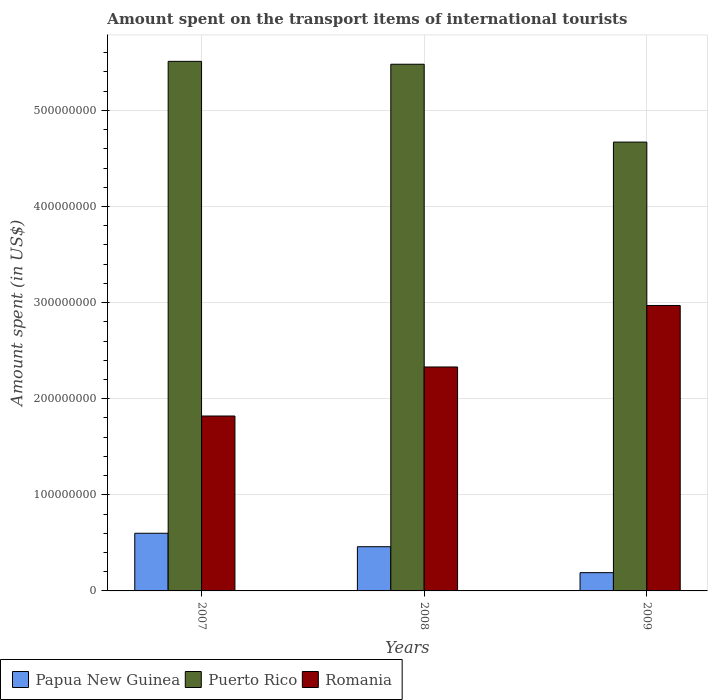How many different coloured bars are there?
Ensure brevity in your answer.  3. How many groups of bars are there?
Provide a short and direct response. 3. How many bars are there on the 3rd tick from the left?
Keep it short and to the point. 3. How many bars are there on the 3rd tick from the right?
Your response must be concise. 3. In how many cases, is the number of bars for a given year not equal to the number of legend labels?
Keep it short and to the point. 0. What is the amount spent on the transport items of international tourists in Puerto Rico in 2009?
Provide a short and direct response. 4.67e+08. Across all years, what is the maximum amount spent on the transport items of international tourists in Papua New Guinea?
Offer a very short reply. 6.00e+07. Across all years, what is the minimum amount spent on the transport items of international tourists in Romania?
Make the answer very short. 1.82e+08. In which year was the amount spent on the transport items of international tourists in Puerto Rico maximum?
Give a very brief answer. 2007. What is the total amount spent on the transport items of international tourists in Papua New Guinea in the graph?
Offer a terse response. 1.25e+08. What is the difference between the amount spent on the transport items of international tourists in Puerto Rico in 2008 and that in 2009?
Ensure brevity in your answer.  8.10e+07. What is the difference between the amount spent on the transport items of international tourists in Romania in 2008 and the amount spent on the transport items of international tourists in Papua New Guinea in 2009?
Give a very brief answer. 2.14e+08. What is the average amount spent on the transport items of international tourists in Papua New Guinea per year?
Provide a short and direct response. 4.17e+07. In the year 2009, what is the difference between the amount spent on the transport items of international tourists in Papua New Guinea and amount spent on the transport items of international tourists in Puerto Rico?
Your answer should be very brief. -4.48e+08. What is the ratio of the amount spent on the transport items of international tourists in Papua New Guinea in 2008 to that in 2009?
Ensure brevity in your answer.  2.42. Is the amount spent on the transport items of international tourists in Puerto Rico in 2007 less than that in 2008?
Ensure brevity in your answer.  No. What is the difference between the highest and the second highest amount spent on the transport items of international tourists in Papua New Guinea?
Offer a terse response. 1.40e+07. What is the difference between the highest and the lowest amount spent on the transport items of international tourists in Romania?
Give a very brief answer. 1.15e+08. Is the sum of the amount spent on the transport items of international tourists in Romania in 2007 and 2009 greater than the maximum amount spent on the transport items of international tourists in Papua New Guinea across all years?
Your answer should be very brief. Yes. What does the 1st bar from the left in 2008 represents?
Offer a terse response. Papua New Guinea. What does the 2nd bar from the right in 2007 represents?
Your answer should be compact. Puerto Rico. Is it the case that in every year, the sum of the amount spent on the transport items of international tourists in Puerto Rico and amount spent on the transport items of international tourists in Romania is greater than the amount spent on the transport items of international tourists in Papua New Guinea?
Your answer should be compact. Yes. How many years are there in the graph?
Make the answer very short. 3. Does the graph contain any zero values?
Your response must be concise. No. Where does the legend appear in the graph?
Provide a short and direct response. Bottom left. How many legend labels are there?
Provide a succinct answer. 3. What is the title of the graph?
Offer a very short reply. Amount spent on the transport items of international tourists. Does "Sweden" appear as one of the legend labels in the graph?
Provide a short and direct response. No. What is the label or title of the Y-axis?
Make the answer very short. Amount spent (in US$). What is the Amount spent (in US$) of Papua New Guinea in 2007?
Ensure brevity in your answer.  6.00e+07. What is the Amount spent (in US$) of Puerto Rico in 2007?
Your answer should be compact. 5.51e+08. What is the Amount spent (in US$) of Romania in 2007?
Provide a succinct answer. 1.82e+08. What is the Amount spent (in US$) of Papua New Guinea in 2008?
Offer a very short reply. 4.60e+07. What is the Amount spent (in US$) of Puerto Rico in 2008?
Offer a terse response. 5.48e+08. What is the Amount spent (in US$) of Romania in 2008?
Give a very brief answer. 2.33e+08. What is the Amount spent (in US$) of Papua New Guinea in 2009?
Your answer should be compact. 1.90e+07. What is the Amount spent (in US$) of Puerto Rico in 2009?
Your answer should be compact. 4.67e+08. What is the Amount spent (in US$) in Romania in 2009?
Provide a short and direct response. 2.97e+08. Across all years, what is the maximum Amount spent (in US$) in Papua New Guinea?
Keep it short and to the point. 6.00e+07. Across all years, what is the maximum Amount spent (in US$) of Puerto Rico?
Make the answer very short. 5.51e+08. Across all years, what is the maximum Amount spent (in US$) of Romania?
Give a very brief answer. 2.97e+08. Across all years, what is the minimum Amount spent (in US$) in Papua New Guinea?
Keep it short and to the point. 1.90e+07. Across all years, what is the minimum Amount spent (in US$) in Puerto Rico?
Make the answer very short. 4.67e+08. Across all years, what is the minimum Amount spent (in US$) in Romania?
Offer a very short reply. 1.82e+08. What is the total Amount spent (in US$) in Papua New Guinea in the graph?
Provide a short and direct response. 1.25e+08. What is the total Amount spent (in US$) of Puerto Rico in the graph?
Provide a succinct answer. 1.57e+09. What is the total Amount spent (in US$) of Romania in the graph?
Keep it short and to the point. 7.12e+08. What is the difference between the Amount spent (in US$) in Papua New Guinea in 2007 and that in 2008?
Keep it short and to the point. 1.40e+07. What is the difference between the Amount spent (in US$) of Puerto Rico in 2007 and that in 2008?
Provide a short and direct response. 3.00e+06. What is the difference between the Amount spent (in US$) of Romania in 2007 and that in 2008?
Your response must be concise. -5.10e+07. What is the difference between the Amount spent (in US$) in Papua New Guinea in 2007 and that in 2009?
Make the answer very short. 4.10e+07. What is the difference between the Amount spent (in US$) of Puerto Rico in 2007 and that in 2009?
Offer a terse response. 8.40e+07. What is the difference between the Amount spent (in US$) in Romania in 2007 and that in 2009?
Your response must be concise. -1.15e+08. What is the difference between the Amount spent (in US$) in Papua New Guinea in 2008 and that in 2009?
Your answer should be very brief. 2.70e+07. What is the difference between the Amount spent (in US$) in Puerto Rico in 2008 and that in 2009?
Make the answer very short. 8.10e+07. What is the difference between the Amount spent (in US$) of Romania in 2008 and that in 2009?
Offer a terse response. -6.40e+07. What is the difference between the Amount spent (in US$) in Papua New Guinea in 2007 and the Amount spent (in US$) in Puerto Rico in 2008?
Your response must be concise. -4.88e+08. What is the difference between the Amount spent (in US$) of Papua New Guinea in 2007 and the Amount spent (in US$) of Romania in 2008?
Provide a short and direct response. -1.73e+08. What is the difference between the Amount spent (in US$) of Puerto Rico in 2007 and the Amount spent (in US$) of Romania in 2008?
Your answer should be very brief. 3.18e+08. What is the difference between the Amount spent (in US$) in Papua New Guinea in 2007 and the Amount spent (in US$) in Puerto Rico in 2009?
Give a very brief answer. -4.07e+08. What is the difference between the Amount spent (in US$) in Papua New Guinea in 2007 and the Amount spent (in US$) in Romania in 2009?
Your answer should be compact. -2.37e+08. What is the difference between the Amount spent (in US$) of Puerto Rico in 2007 and the Amount spent (in US$) of Romania in 2009?
Keep it short and to the point. 2.54e+08. What is the difference between the Amount spent (in US$) in Papua New Guinea in 2008 and the Amount spent (in US$) in Puerto Rico in 2009?
Offer a terse response. -4.21e+08. What is the difference between the Amount spent (in US$) of Papua New Guinea in 2008 and the Amount spent (in US$) of Romania in 2009?
Provide a short and direct response. -2.51e+08. What is the difference between the Amount spent (in US$) in Puerto Rico in 2008 and the Amount spent (in US$) in Romania in 2009?
Give a very brief answer. 2.51e+08. What is the average Amount spent (in US$) in Papua New Guinea per year?
Your answer should be compact. 4.17e+07. What is the average Amount spent (in US$) of Puerto Rico per year?
Give a very brief answer. 5.22e+08. What is the average Amount spent (in US$) of Romania per year?
Your answer should be compact. 2.37e+08. In the year 2007, what is the difference between the Amount spent (in US$) in Papua New Guinea and Amount spent (in US$) in Puerto Rico?
Your answer should be compact. -4.91e+08. In the year 2007, what is the difference between the Amount spent (in US$) of Papua New Guinea and Amount spent (in US$) of Romania?
Give a very brief answer. -1.22e+08. In the year 2007, what is the difference between the Amount spent (in US$) in Puerto Rico and Amount spent (in US$) in Romania?
Offer a very short reply. 3.69e+08. In the year 2008, what is the difference between the Amount spent (in US$) in Papua New Guinea and Amount spent (in US$) in Puerto Rico?
Provide a succinct answer. -5.02e+08. In the year 2008, what is the difference between the Amount spent (in US$) in Papua New Guinea and Amount spent (in US$) in Romania?
Give a very brief answer. -1.87e+08. In the year 2008, what is the difference between the Amount spent (in US$) in Puerto Rico and Amount spent (in US$) in Romania?
Offer a terse response. 3.15e+08. In the year 2009, what is the difference between the Amount spent (in US$) in Papua New Guinea and Amount spent (in US$) in Puerto Rico?
Provide a short and direct response. -4.48e+08. In the year 2009, what is the difference between the Amount spent (in US$) in Papua New Guinea and Amount spent (in US$) in Romania?
Your answer should be very brief. -2.78e+08. In the year 2009, what is the difference between the Amount spent (in US$) of Puerto Rico and Amount spent (in US$) of Romania?
Your response must be concise. 1.70e+08. What is the ratio of the Amount spent (in US$) of Papua New Guinea in 2007 to that in 2008?
Offer a terse response. 1.3. What is the ratio of the Amount spent (in US$) in Romania in 2007 to that in 2008?
Ensure brevity in your answer.  0.78. What is the ratio of the Amount spent (in US$) of Papua New Guinea in 2007 to that in 2009?
Keep it short and to the point. 3.16. What is the ratio of the Amount spent (in US$) of Puerto Rico in 2007 to that in 2009?
Keep it short and to the point. 1.18. What is the ratio of the Amount spent (in US$) of Romania in 2007 to that in 2009?
Your response must be concise. 0.61. What is the ratio of the Amount spent (in US$) in Papua New Guinea in 2008 to that in 2009?
Offer a terse response. 2.42. What is the ratio of the Amount spent (in US$) of Puerto Rico in 2008 to that in 2009?
Ensure brevity in your answer.  1.17. What is the ratio of the Amount spent (in US$) in Romania in 2008 to that in 2009?
Offer a very short reply. 0.78. What is the difference between the highest and the second highest Amount spent (in US$) of Papua New Guinea?
Ensure brevity in your answer.  1.40e+07. What is the difference between the highest and the second highest Amount spent (in US$) in Romania?
Your response must be concise. 6.40e+07. What is the difference between the highest and the lowest Amount spent (in US$) in Papua New Guinea?
Provide a succinct answer. 4.10e+07. What is the difference between the highest and the lowest Amount spent (in US$) of Puerto Rico?
Provide a short and direct response. 8.40e+07. What is the difference between the highest and the lowest Amount spent (in US$) in Romania?
Your answer should be very brief. 1.15e+08. 